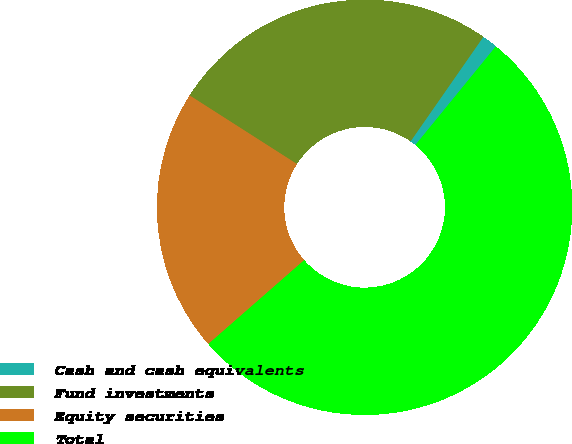Convert chart to OTSL. <chart><loc_0><loc_0><loc_500><loc_500><pie_chart><fcel>Cash and cash equivalents<fcel>Fund investments<fcel>Equity securities<fcel>Total<nl><fcel>1.21%<fcel>25.63%<fcel>20.49%<fcel>52.67%<nl></chart> 